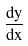Convert formula to latex. <formula><loc_0><loc_0><loc_500><loc_500>\frac { d y } { d x }</formula> 